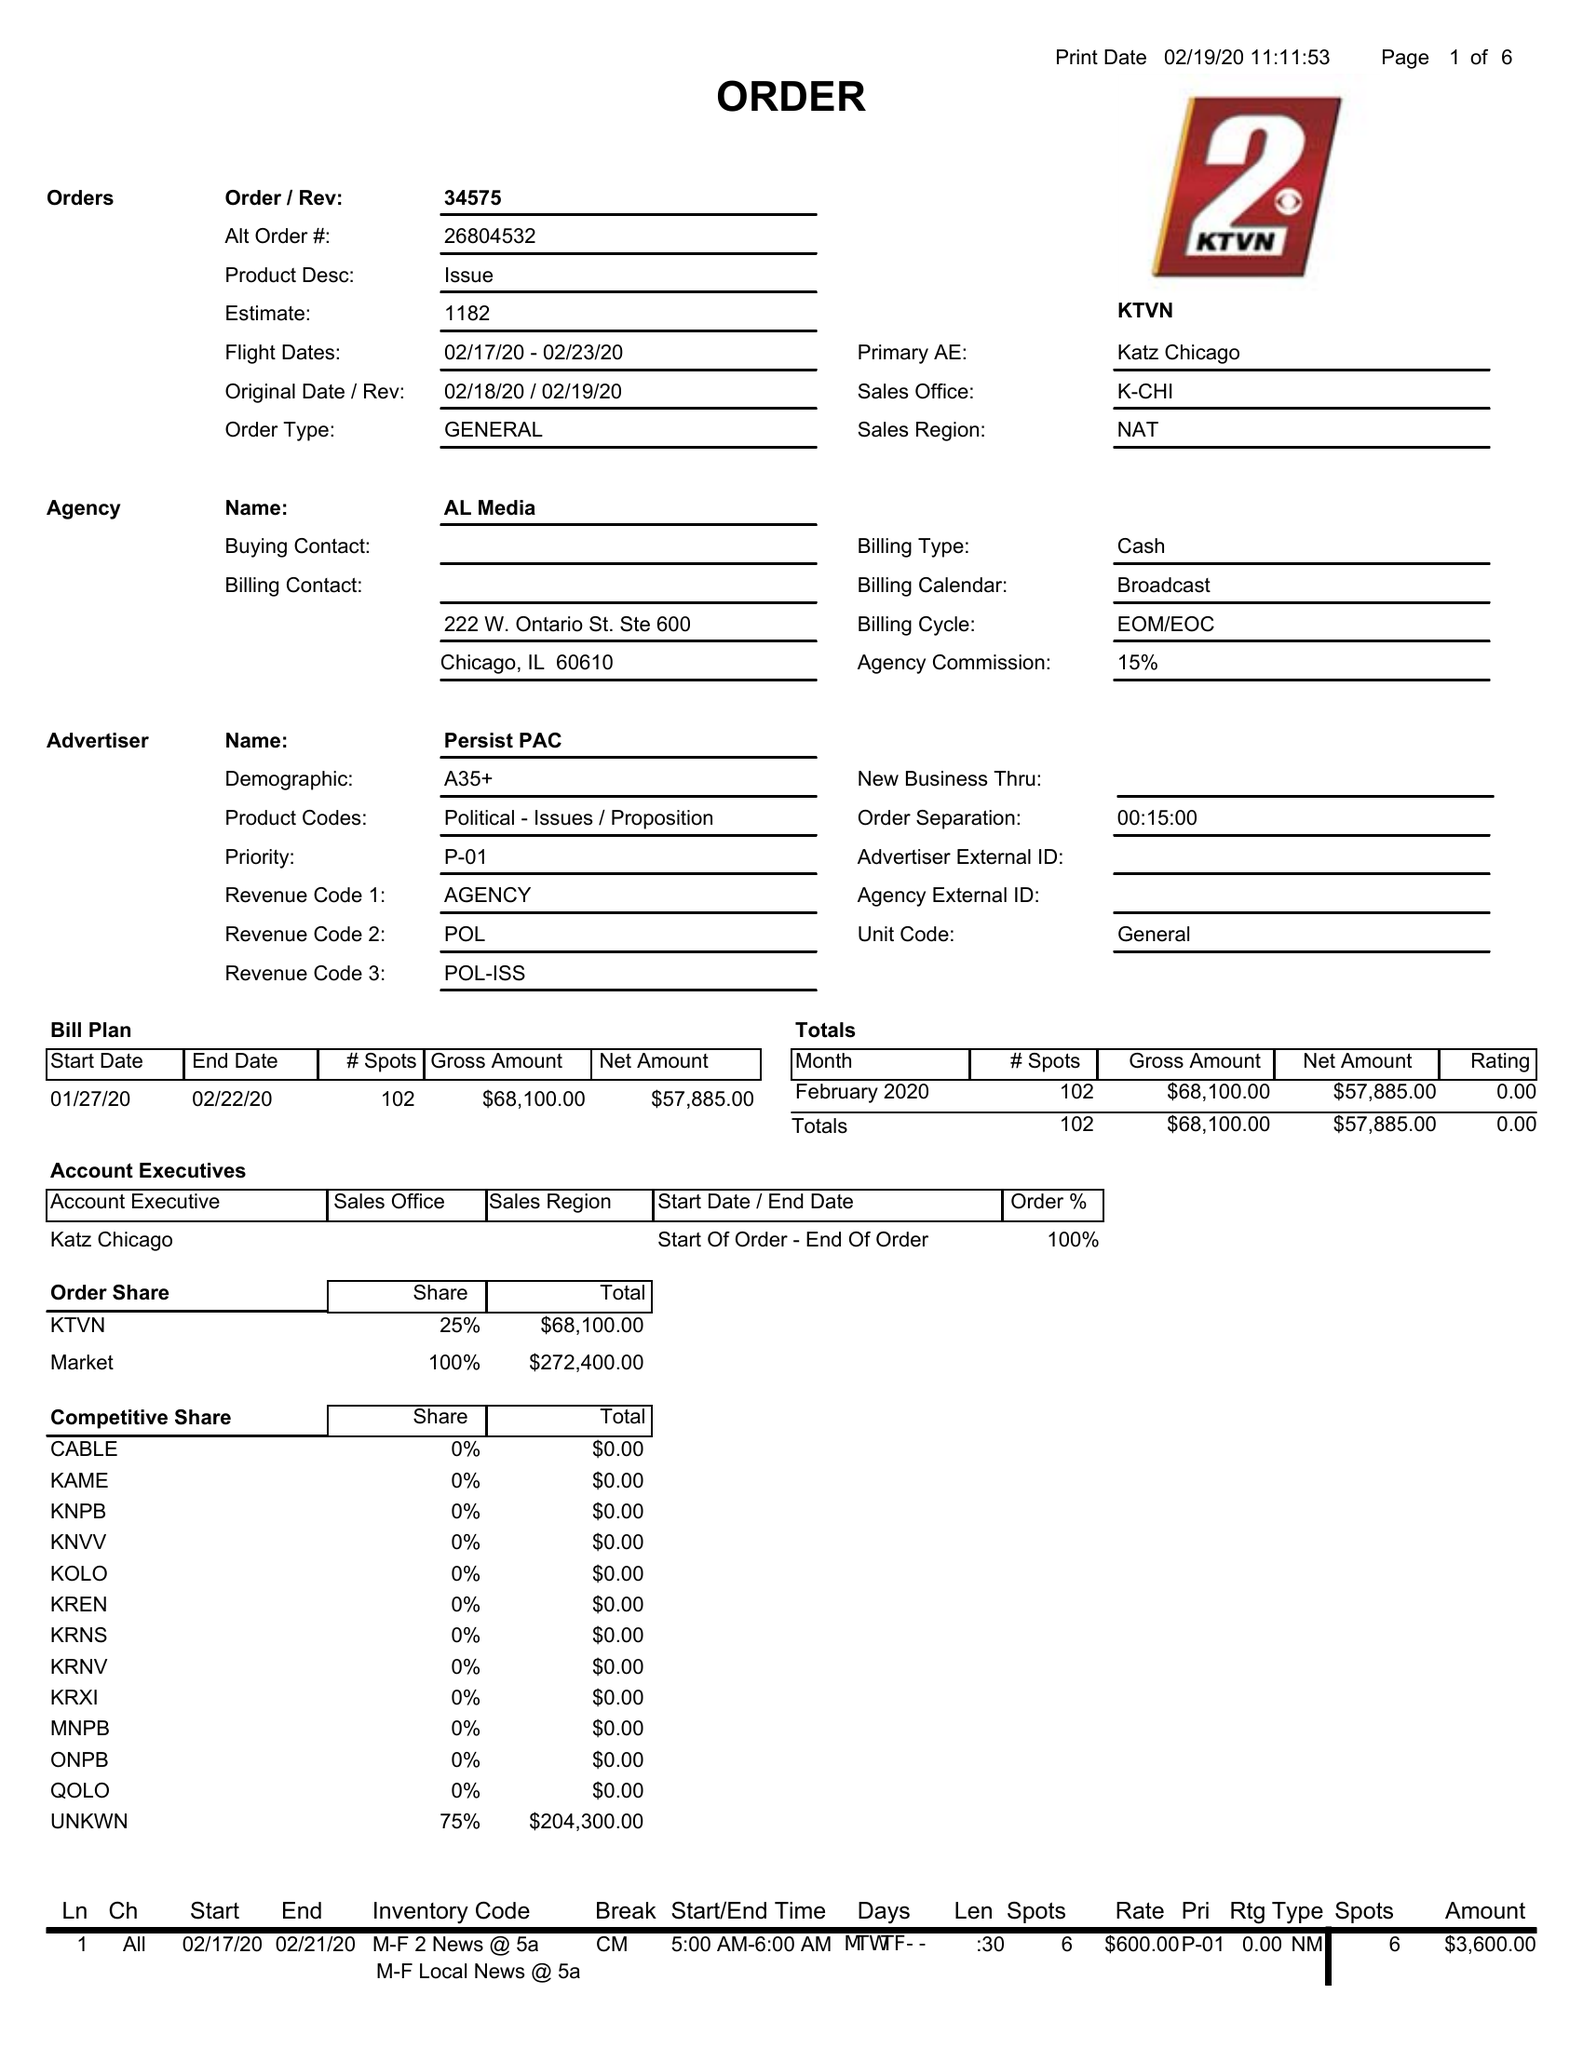What is the value for the flight_to?
Answer the question using a single word or phrase. 02/23/20 